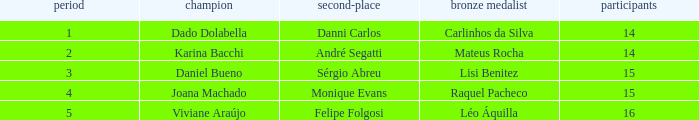How many contestants were there when the runner-up was Monique Evans? 15.0. 